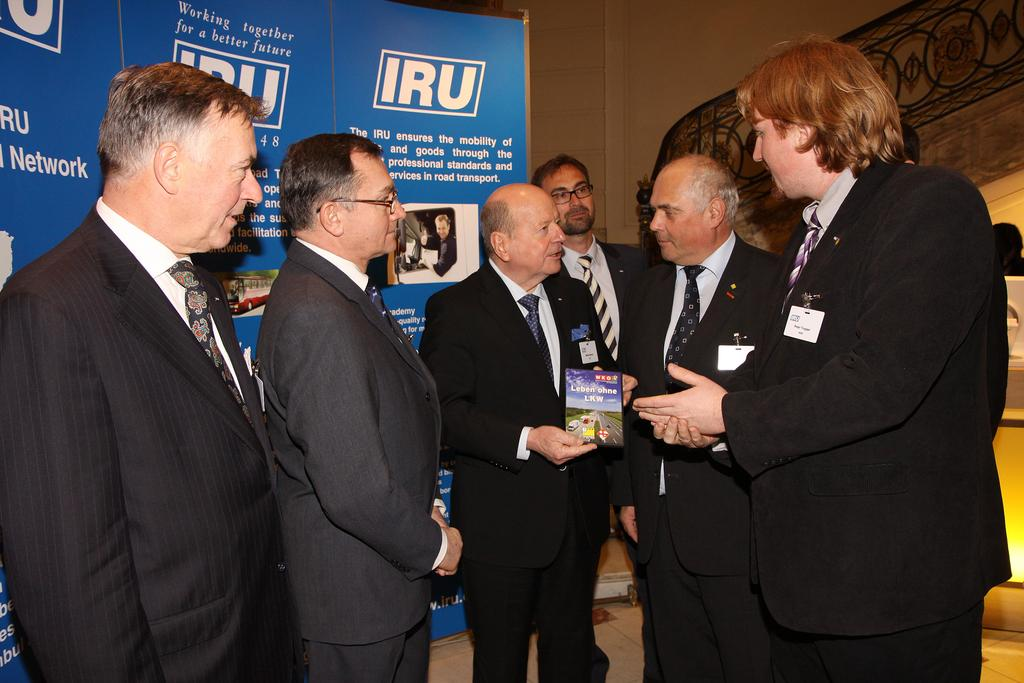How many people are present in the image? There are people standing in the image, but the exact number is not specified. What is the person holding in the image? One person is holding an object, but the nature of the object is not described. What can be seen on the poster in the background? There is a poster with images and text in the background, but the content of the poster is not mentioned. What type of structure is visible in the image? There is a wall visible in the image, but its purpose or significance is not explained. How many gates are present in the image? There is no mention of gates in the image, so it is not possible to determine their presence or number. 